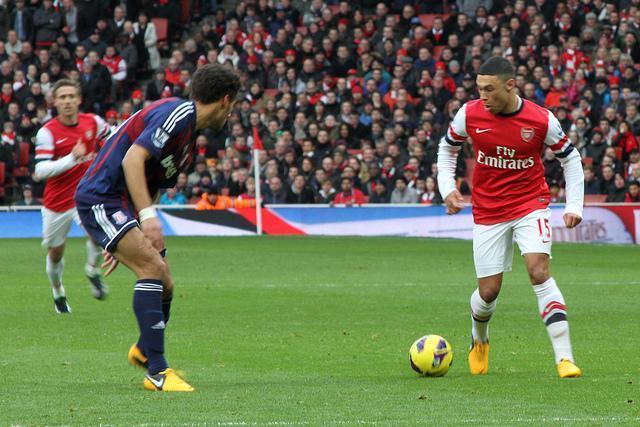How many people are visible?
Give a very brief answer. 4. 